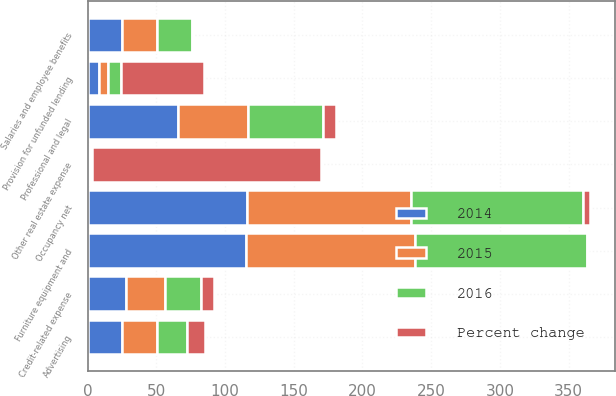Convert chart to OTSL. <chart><loc_0><loc_0><loc_500><loc_500><stacked_bar_chart><ecel><fcel>Salaries and employee benefits<fcel>Occupancy net<fcel>Furniture equipment and<fcel>Other real estate expense<fcel>Credit-related expense<fcel>Provision for unfunded lending<fcel>Professional and legal<fcel>Advertising<nl><fcel>2016<fcel>25.3<fcel>125.3<fcel>124.7<fcel>1.6<fcel>25.7<fcel>9.9<fcel>55.1<fcel>22.1<nl><fcel>Percent change<fcel>1<fcel>4.9<fcel>1.2<fcel>166.7<fcel>9.8<fcel>59.7<fcel>9.3<fcel>12.6<nl><fcel>2015<fcel>25.3<fcel>119.5<fcel>123.2<fcel>0.6<fcel>28.5<fcel>6.2<fcel>50.4<fcel>25.3<nl><fcel>2014<fcel>25.3<fcel>115.7<fcel>115.3<fcel>1.2<fcel>28.1<fcel>8.6<fcel>66<fcel>25.1<nl></chart> 